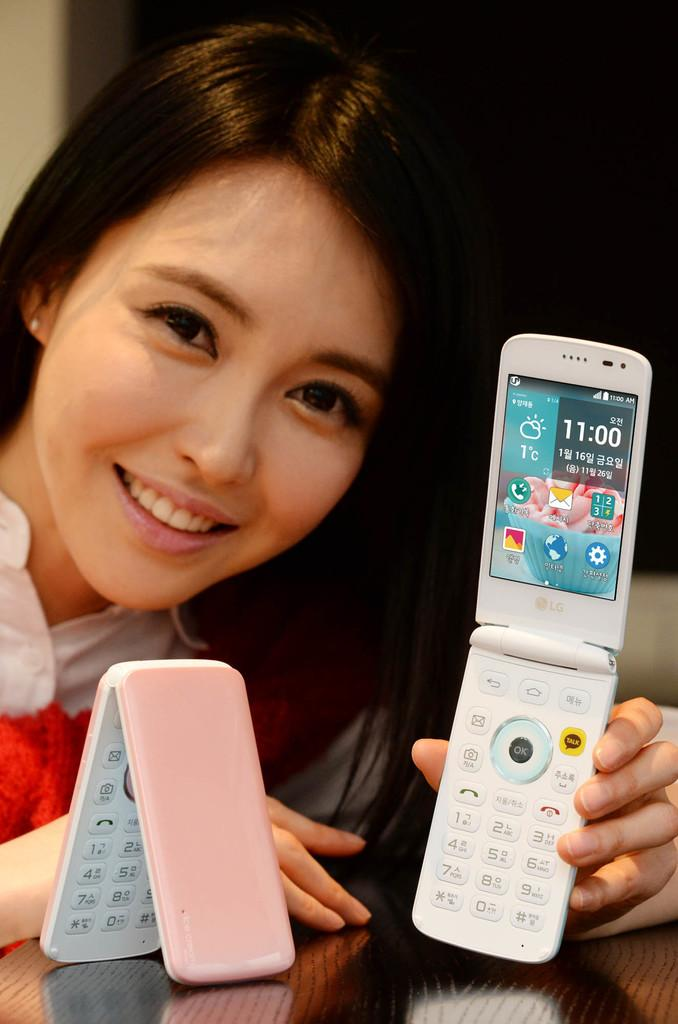Provide a one-sentence caption for the provided image. The lady is holding a white cell phone showing the time as 11:00. 